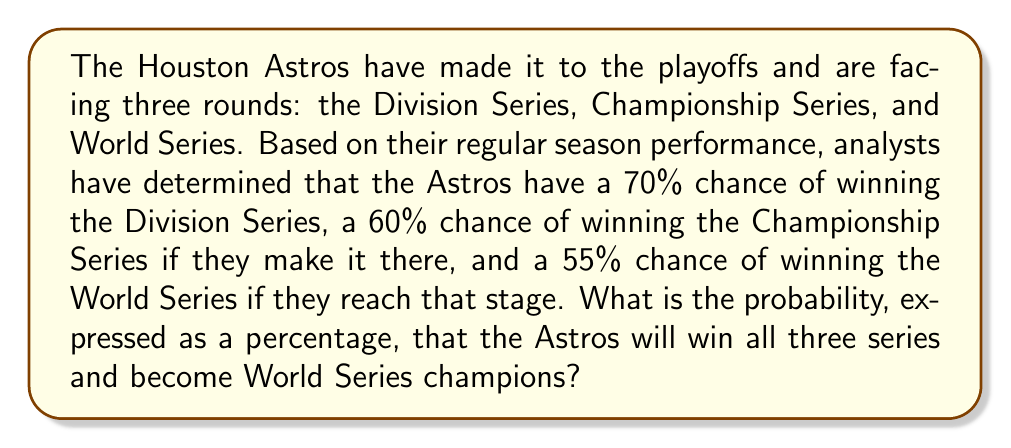Solve this math problem. To solve this problem, we need to use the concept of independent events and multiply the probabilities of each event occurring.

1. First, let's convert the given percentages to probabilities:
   Division Series: 70% = 0.70
   Championship Series: 60% = 0.60
   World Series: 55% = 0.55

2. For the Astros to become World Series champions, they need to win all three series in succession. This means we need to calculate the probability of all three events occurring together.

3. When we have independent events that all need to occur, we multiply their individual probabilities:

   $P(\text{World Series Champions}) = P(\text{Win DS}) \times P(\text{Win CS}) \times P(\text{Win WS})$

4. Substituting the values:

   $P(\text{World Series Champions}) = 0.70 \times 0.60 \times 0.55$

5. Calculating:

   $P(\text{World Series Champions}) = 0.231$

6. To convert this probability back to a percentage, we multiply by 100:

   $0.231 \times 100 = 23.1\%$

Therefore, the Astros have a 23.1% chance of winning all three series and becoming World Series champions.
Answer: 23.1% 